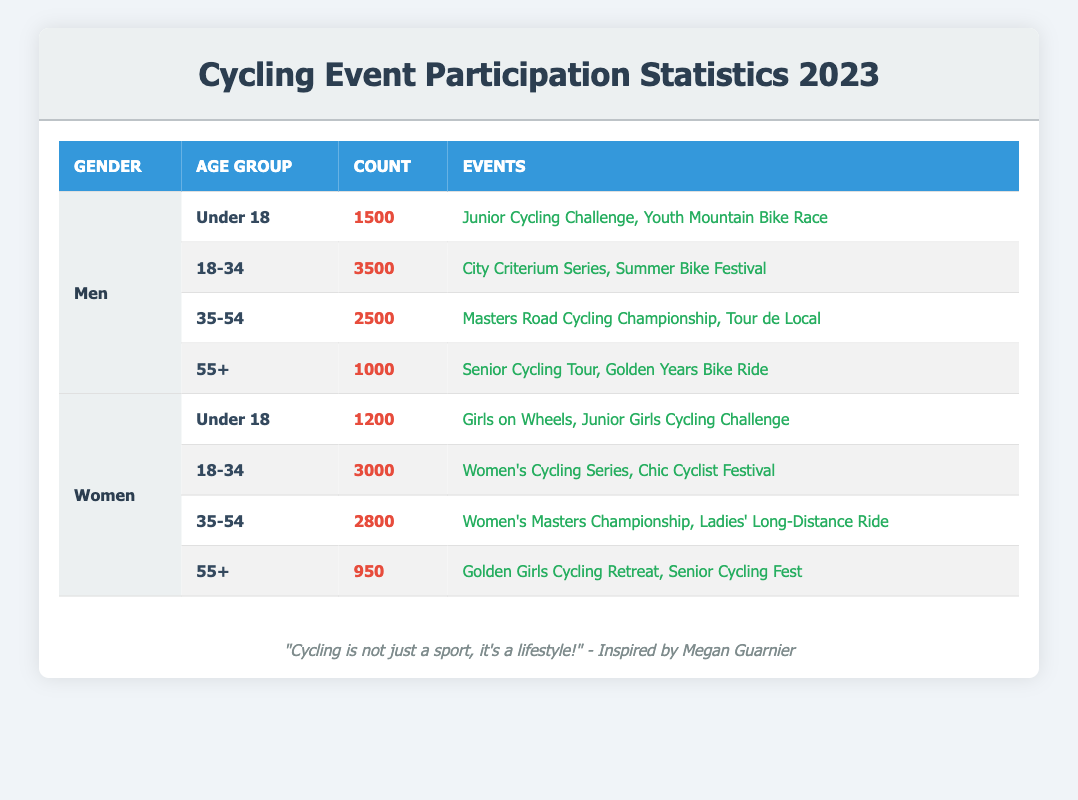What is the total number of men participating in cycling events aged 35-54? The count of men in the 35-54 age group is directly given in the table as 2500.
Answer: 2500 Which age group has the highest number of female participants? To find the age group with the highest female participation, we compare the counts: Under 18 (1200), 18-34 (3000), 35-54 (2800), 55+ (950). The highest count is 3000 in the 18-34 age group.
Answer: 18-34 Is it true that more women participate in cycling events under 18 than men? The count for women under 18 is 1200, and for men under 18, it is 1500. Since 1200 is less than 1500, the statement is false.
Answer: No What is the combined total of male and female participants aged 55 and over? For men aged 55+, the count is 1000, and for women aged 55+, it is 950. Adding these gives a total of 1000 + 950 = 1950 participants aged 55 and over.
Answer: 1950 What percentage of total male participants are aged 18-34? The total male participants across all age groups are 1500 + 3500 + 2500 + 1000 = 8500. The count for the 18-34 age group is 3500. The percentage is calculated as (3500/8500) * 100, which is approximately 41.18%.
Answer: 41.18% How many more male participants are there in the 18-34 age group compared to the 55+ age group? The count of male participants in the 18-34 age group is 3500, and in the 55+ age group it is 1000. The difference is 3500 - 1000 = 2500 more male participants in the 18-34 age group.
Answer: 2500 Which event has the highest participation among men aged 35-54 based on the events listed? The events listed for men aged 35-54 are the "Masters Road Cycling Championship" and "Tour de Local". However, the table does not provide specific participation numbers per event, so we can't determine which event has the highest participation based only on this information.
Answer: Not determinable What is the total number of participants across all age groups and genders? To find the total, we add together all counts: men (1500 + 3500 + 2500 + 1000 = 8500) and women (1200 + 3000 + 2800 + 950 = 7950). The combined total is 8500 + 7950 = 16450.
Answer: 16450 